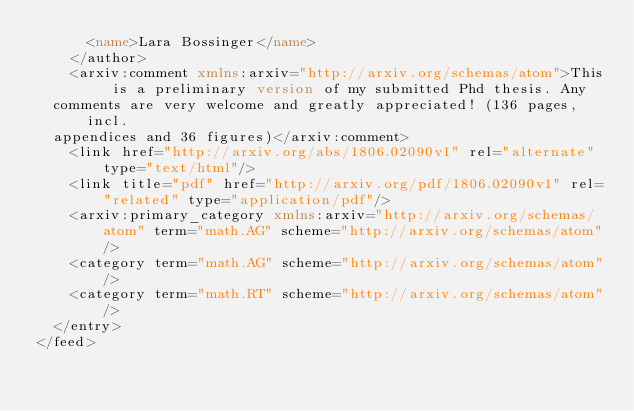Convert code to text. <code><loc_0><loc_0><loc_500><loc_500><_XML_>      <name>Lara Bossinger</name>
    </author>
    <arxiv:comment xmlns:arxiv="http://arxiv.org/schemas/atom">This is a preliminary version of my submitted Phd thesis. Any
  comments are very welcome and greatly appreciated! (136 pages, incl.
  appendices and 36 figures)</arxiv:comment>
    <link href="http://arxiv.org/abs/1806.02090v1" rel="alternate" type="text/html"/>
    <link title="pdf" href="http://arxiv.org/pdf/1806.02090v1" rel="related" type="application/pdf"/>
    <arxiv:primary_category xmlns:arxiv="http://arxiv.org/schemas/atom" term="math.AG" scheme="http://arxiv.org/schemas/atom"/>
    <category term="math.AG" scheme="http://arxiv.org/schemas/atom"/>
    <category term="math.RT" scheme="http://arxiv.org/schemas/atom"/>
  </entry>
</feed>
</code> 